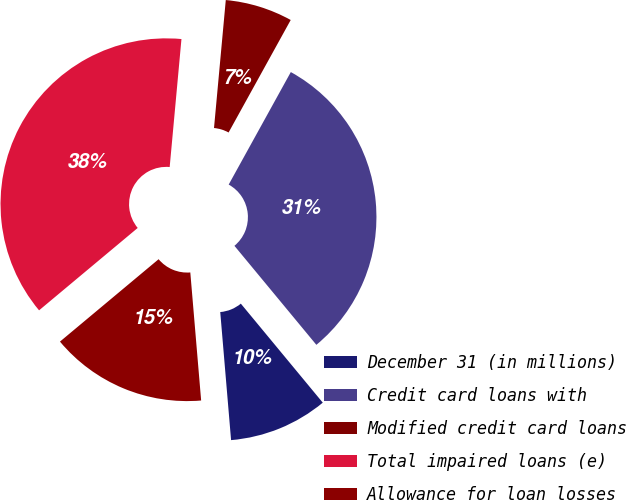Convert chart to OTSL. <chart><loc_0><loc_0><loc_500><loc_500><pie_chart><fcel>December 31 (in millions)<fcel>Credit card loans with<fcel>Modified credit card loans<fcel>Total impaired loans (e)<fcel>Allowance for loan losses<nl><fcel>9.66%<fcel>30.97%<fcel>6.57%<fcel>37.54%<fcel>15.27%<nl></chart> 